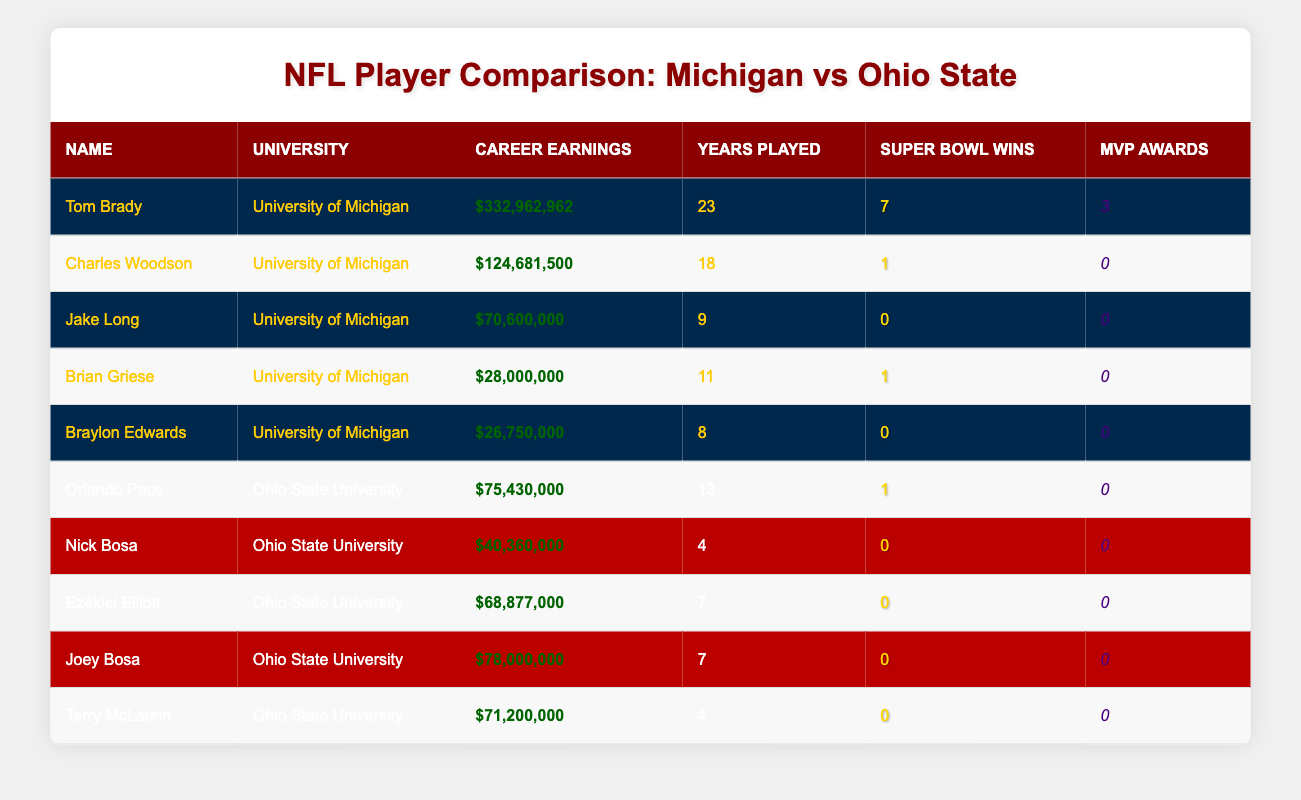What is the highest career earnings of a player from the University of Michigan? From the table, Tom Brady has the highest career earnings listed as $332,962,962.
Answer: $332,962,962 How many Super Bowl wins does Charles Woodson have? The table shows that Charles Woodson has 1 Super Bowl win.
Answer: 1 What is the total career earnings of all Ohio State University players listed in the table? The career earnings for Ohio State players are: Orlando Pace: $75,430,000; Nick Bosa: $40,360,000; Ezekiel Elliott: $68,877,000; Joey Bosa: $78,000,000; and Terry McLaurin: $71,200,000. Summing these gives: 75,430,000 + 40,360,000 + 68,877,000 + 78,000,000 + 71,200,000 = $334,867,000.
Answer: $334,867,000 Is it true that all players from Ohio State University in the table have zero MVP awards? Looking at the MVP awards column for Ohio State players, Nick Bosa, Ezekiel Elliott, Joey Bosa, and Terry McLaurin all have 0 MVP awards. Since they all have the same value, the statement is true.
Answer: Yes Which player from Ohio State University has the highest career earnings? Referring to the career earnings for Ohio State players, Joey Bosa with $78,000,000 has the highest amount.
Answer: $78,000,000 What is the average career earnings of players from the University of Michigan? The players from Michigan are Tom Brady ($332,962,962), Charles Woodson ($124,681,500), Jake Long ($70,600,000), Brian Griese ($28,000,000), and Braylon Edwards ($26,750,000). Adding these values gives $682,994,462. There are 5 players, so the average is $682,994,462 / 5 = $136,598,892.4.
Answer: $136,598,892.4 How many years did the player with the highest career earnings play? Tom Brady, the player with the highest earnings of $332,962,962, played for 23 years according to the table.
Answer: 23 years Which university has more players with Super Bowl wins, Michigan or Ohio State? From the table, Michigan players with Super Bowl wins are Tom Brady (7) and Brian Griese (1), totaling 2. Ohio State has Orlando Pace with 1 Super Bowl win. Therefore, Michigan has more players with Super Bowl wins.
Answer: Michigan What is the difference in career earnings between the highest earning Michigan player and the highest earning Ohio State player? Tom Brady (Michigan) has $332,962,962 while Joey Bosa (Ohio State) has $78,000,000. The difference is $332,962,962 - $78,000,000 = $254,962,962.
Answer: $254,962,962 